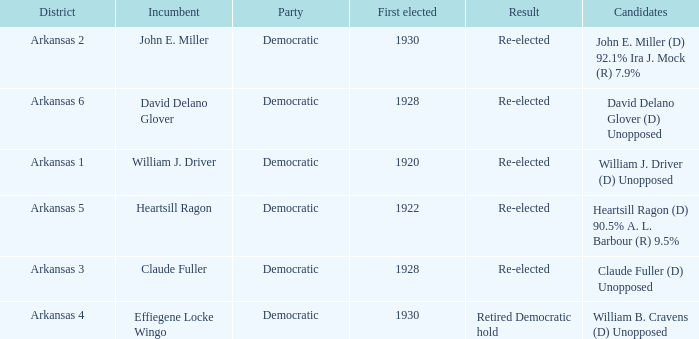What year was incumbent Claude Fuller first elected?  1928.0. 